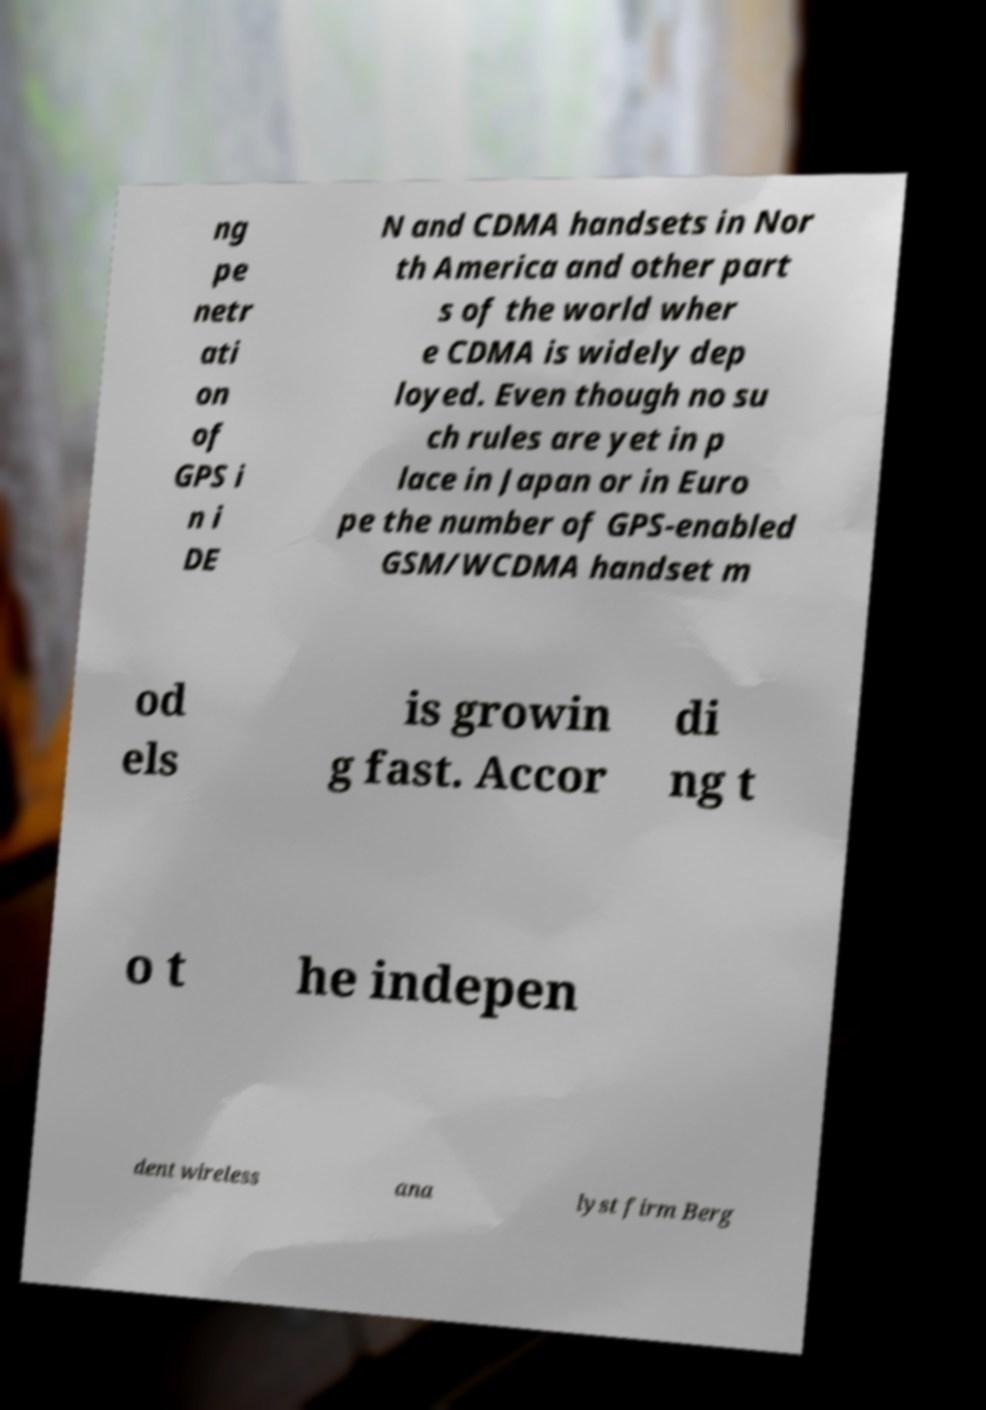I need the written content from this picture converted into text. Can you do that? ng pe netr ati on of GPS i n i DE N and CDMA handsets in Nor th America and other part s of the world wher e CDMA is widely dep loyed. Even though no su ch rules are yet in p lace in Japan or in Euro pe the number of GPS-enabled GSM/WCDMA handset m od els is growin g fast. Accor di ng t o t he indepen dent wireless ana lyst firm Berg 